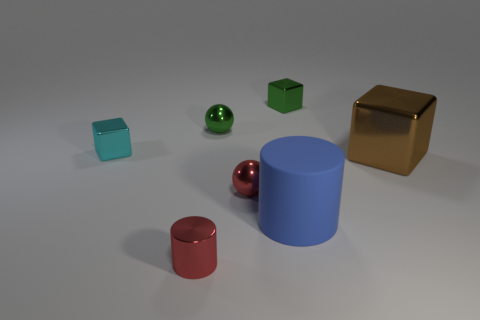Add 1 purple blocks. How many objects exist? 8 Subtract all cyan blocks. How many blocks are left? 2 Subtract 1 green cubes. How many objects are left? 6 Subtract all cylinders. How many objects are left? 5 Subtract 2 blocks. How many blocks are left? 1 Subtract all yellow cubes. Subtract all red spheres. How many cubes are left? 3 Subtract all brown blocks. How many green spheres are left? 1 Subtract all green blocks. Subtract all green metal balls. How many objects are left? 5 Add 4 large brown shiny things. How many large brown shiny things are left? 5 Add 4 spheres. How many spheres exist? 6 